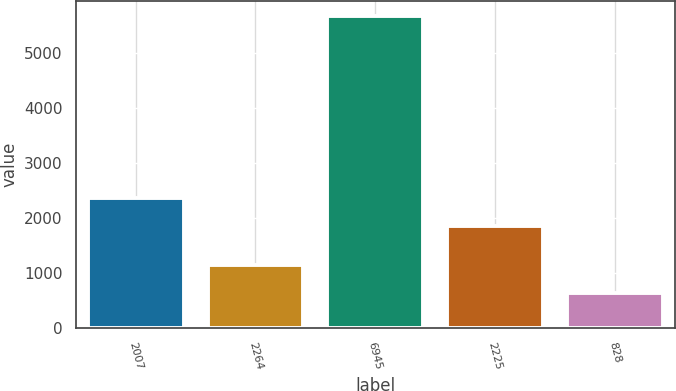Convert chart. <chart><loc_0><loc_0><loc_500><loc_500><bar_chart><fcel>2007<fcel>2264<fcel>6945<fcel>2225<fcel>828<nl><fcel>2362<fcel>1146<fcel>5664<fcel>1860<fcel>644<nl></chart> 